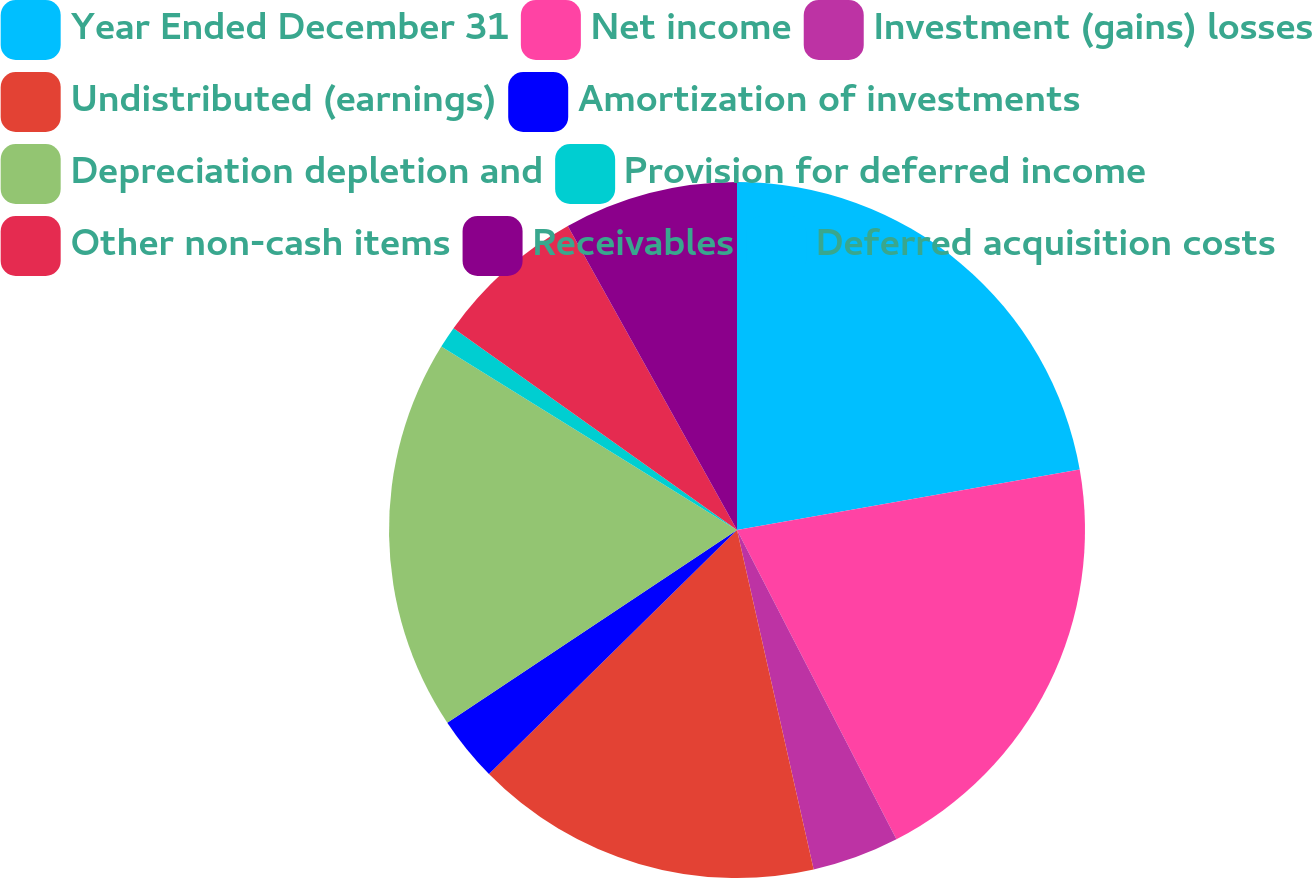Convert chart. <chart><loc_0><loc_0><loc_500><loc_500><pie_chart><fcel>Year Ended December 31<fcel>Net income<fcel>Investment (gains) losses<fcel>Undistributed (earnings)<fcel>Amortization of investments<fcel>Depreciation depletion and<fcel>Provision for deferred income<fcel>Other non-cash items<fcel>Receivables<fcel>Deferred acquisition costs<nl><fcel>22.22%<fcel>20.2%<fcel>4.04%<fcel>16.16%<fcel>3.03%<fcel>18.18%<fcel>1.01%<fcel>7.07%<fcel>8.08%<fcel>0.0%<nl></chart> 